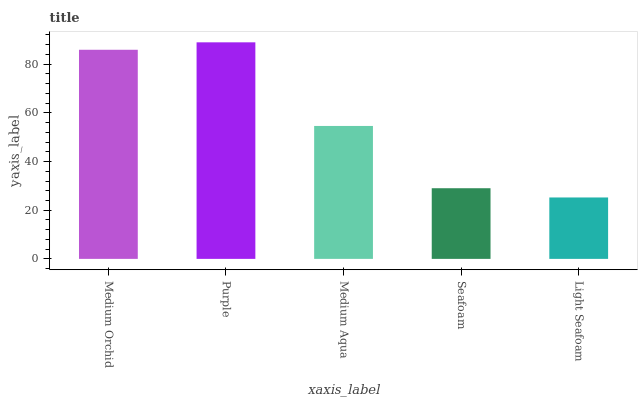Is Medium Aqua the minimum?
Answer yes or no. No. Is Medium Aqua the maximum?
Answer yes or no. No. Is Purple greater than Medium Aqua?
Answer yes or no. Yes. Is Medium Aqua less than Purple?
Answer yes or no. Yes. Is Medium Aqua greater than Purple?
Answer yes or no. No. Is Purple less than Medium Aqua?
Answer yes or no. No. Is Medium Aqua the high median?
Answer yes or no. Yes. Is Medium Aqua the low median?
Answer yes or no. Yes. Is Seafoam the high median?
Answer yes or no. No. Is Light Seafoam the low median?
Answer yes or no. No. 